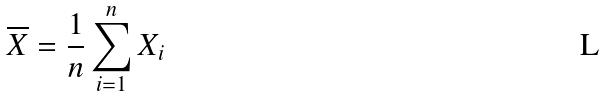<formula> <loc_0><loc_0><loc_500><loc_500>\overline { X } = \frac { 1 } { n } \sum _ { i = 1 } ^ { n } X _ { i }</formula> 